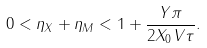<formula> <loc_0><loc_0><loc_500><loc_500>0 < \eta _ { X } + \eta _ { M } < 1 + \frac { Y \pi } { 2 X _ { 0 } V \tau } .</formula> 